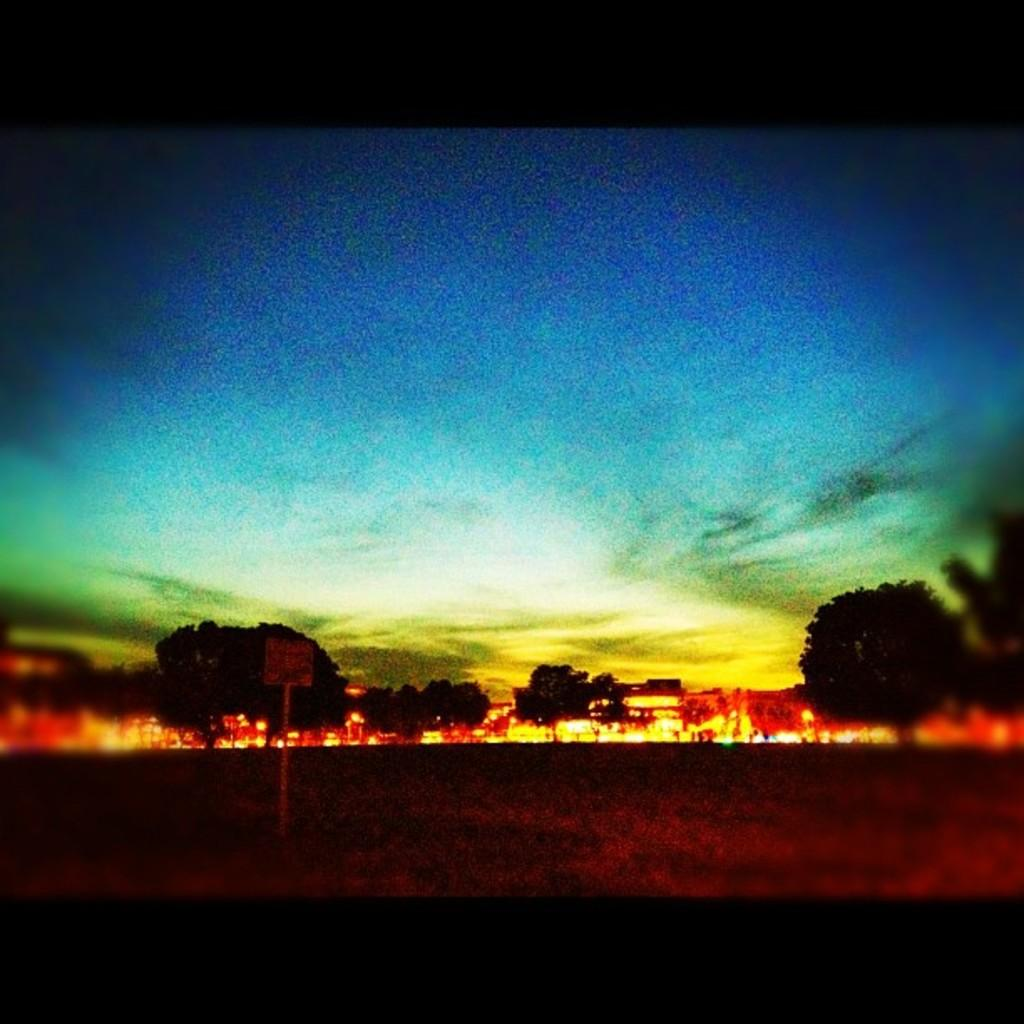Where was the image taken? The image was taken outdoors. Has the image been altered in any way? Yes, the image has been edited. What can be seen in the background of the image? There are trees in the background of the image. What is visible at the top of the image? The sky is visible at the top of the image. What can be observed in the sky? Clouds are present in the sky. What type of stocking is the tree wearing in the image? There are no stockings present in the image, as trees do not wear clothing. What type of collar can be seen on the clouds in the image? There are no collars present on the clouds in the image, as clouds do not have collars. 